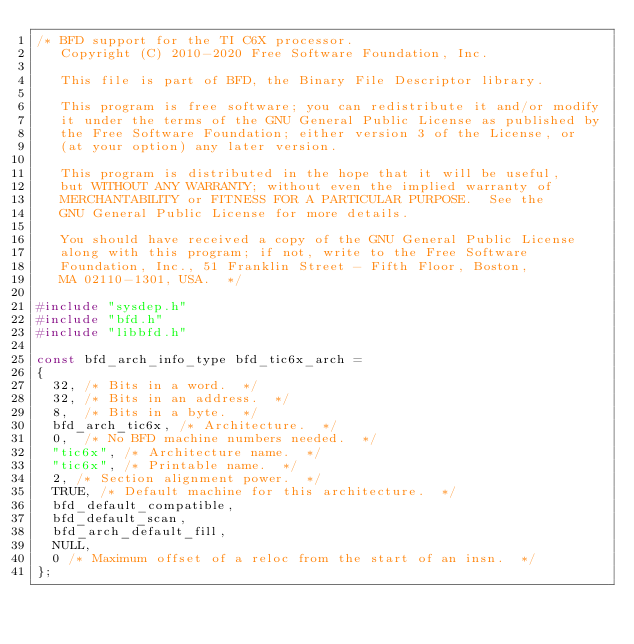<code> <loc_0><loc_0><loc_500><loc_500><_C_>/* BFD support for the TI C6X processor.
   Copyright (C) 2010-2020 Free Software Foundation, Inc.

   This file is part of BFD, the Binary File Descriptor library.

   This program is free software; you can redistribute it and/or modify
   it under the terms of the GNU General Public License as published by
   the Free Software Foundation; either version 3 of the License, or
   (at your option) any later version.

   This program is distributed in the hope that it will be useful,
   but WITHOUT ANY WARRANTY; without even the implied warranty of
   MERCHANTABILITY or FITNESS FOR A PARTICULAR PURPOSE.  See the
   GNU General Public License for more details.

   You should have received a copy of the GNU General Public License
   along with this program; if not, write to the Free Software
   Foundation, Inc., 51 Franklin Street - Fifth Floor, Boston,
   MA 02110-1301, USA.  */

#include "sysdep.h"
#include "bfd.h"
#include "libbfd.h"

const bfd_arch_info_type bfd_tic6x_arch =
{
  32, /* Bits in a word.  */
  32, /* Bits in an address.  */
  8,  /* Bits in a byte.  */
  bfd_arch_tic6x, /* Architecture.  */
  0,  /* No BFD machine numbers needed.  */
  "tic6x", /* Architecture name.  */
  "tic6x", /* Printable name.  */
  2, /* Section alignment power.  */
  TRUE, /* Default machine for this architecture.  */
  bfd_default_compatible,
  bfd_default_scan,
  bfd_arch_default_fill,
  NULL,
  0 /* Maximum offset of a reloc from the start of an insn.  */
};
</code> 